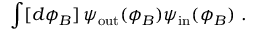Convert formula to latex. <formula><loc_0><loc_0><loc_500><loc_500>\int [ d \phi _ { B } ] \, \psi _ { o u t } ( \phi _ { B } ) \psi _ { i n } ( \phi _ { B } ) \ .</formula> 